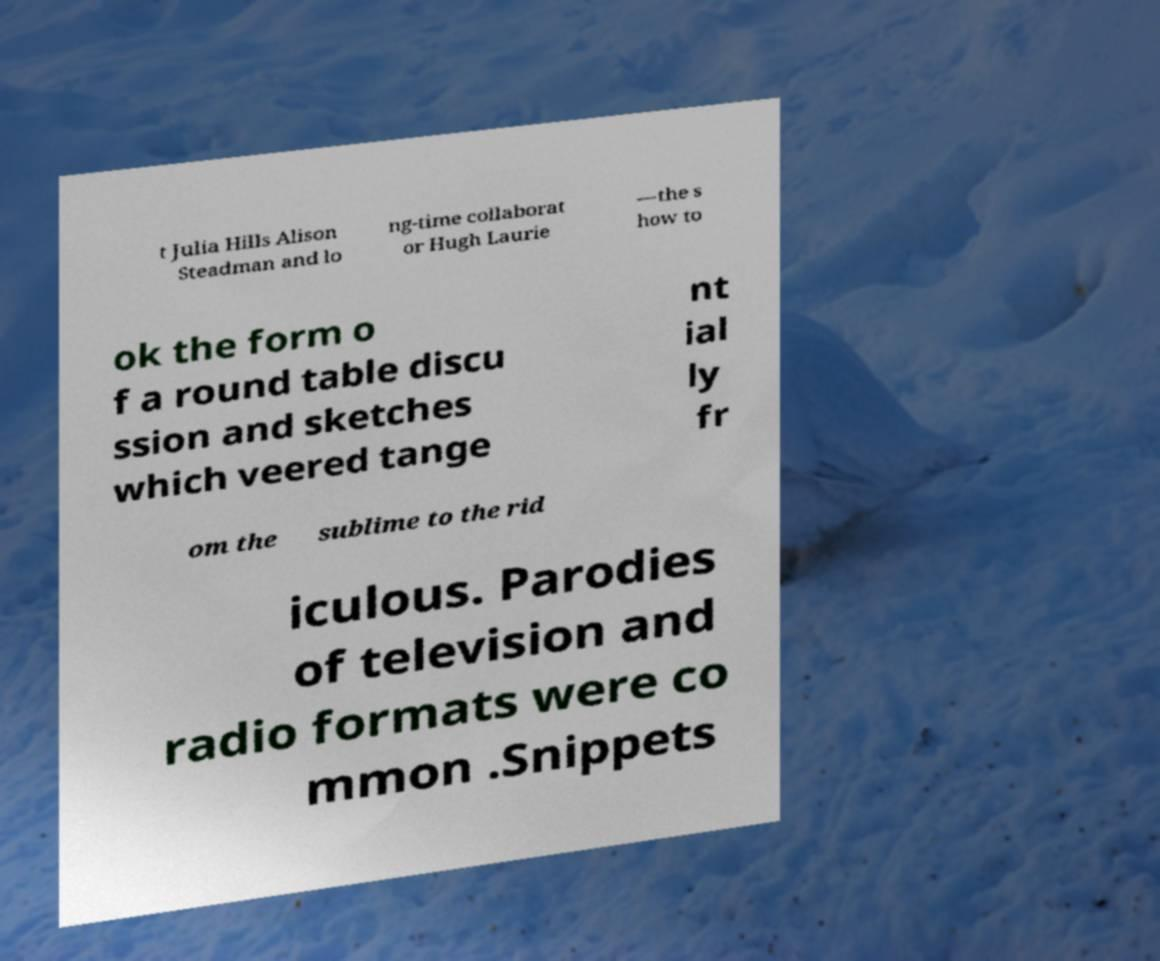Could you extract and type out the text from this image? t Julia Hills Alison Steadman and lo ng-time collaborat or Hugh Laurie —the s how to ok the form o f a round table discu ssion and sketches which veered tange nt ial ly fr om the sublime to the rid iculous. Parodies of television and radio formats were co mmon .Snippets 